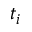Convert formula to latex. <formula><loc_0><loc_0><loc_500><loc_500>t _ { i }</formula> 